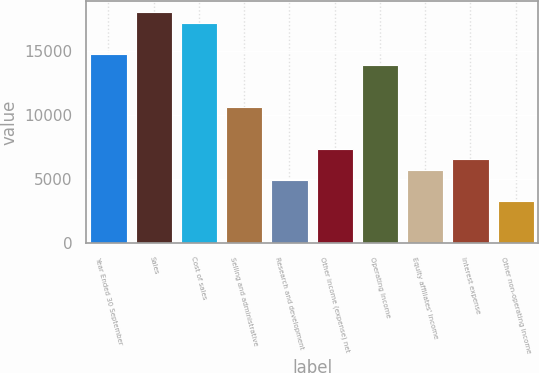Convert chart. <chart><loc_0><loc_0><loc_500><loc_500><bar_chart><fcel>Year Ended 30 September<fcel>Sales<fcel>Cost of sales<fcel>Selling and administrative<fcel>Research and development<fcel>Other income (expense) net<fcel>Operating Income<fcel>Equity affiliates' income<fcel>Interest expense<fcel>Other non-operating income<nl><fcel>14733.5<fcel>18006.4<fcel>17188.2<fcel>10642.3<fcel>4914.6<fcel>7369.32<fcel>13915.2<fcel>5732.84<fcel>6551.08<fcel>3278.12<nl></chart> 